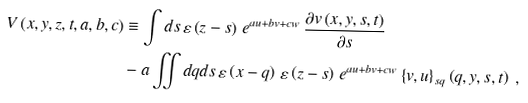<formula> <loc_0><loc_0><loc_500><loc_500>V \left ( x , y , z , t , a , b , c \right ) & \equiv \int d s \, \varepsilon \left ( z - s \right ) \, e ^ { a u + b v + c w } \, \frac { \partial v \left ( x , y , s , t \right ) } { \partial s } \\ & - a \iint d q d s \, \varepsilon \left ( x - q \right ) \, \varepsilon \left ( z - s \right ) \, e ^ { a u + b v + c w } \left \{ v , u \right \} _ { s q } \left ( q , y , s , t \right ) \ ,</formula> 